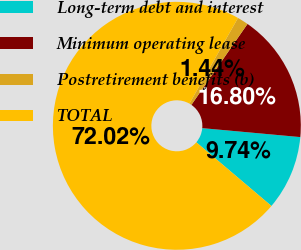Convert chart to OTSL. <chart><loc_0><loc_0><loc_500><loc_500><pie_chart><fcel>Long-term debt and interest<fcel>Minimum operating lease<fcel>Postretirement benefits (b)<fcel>TOTAL<nl><fcel>9.74%<fcel>16.8%<fcel>1.44%<fcel>72.02%<nl></chart> 